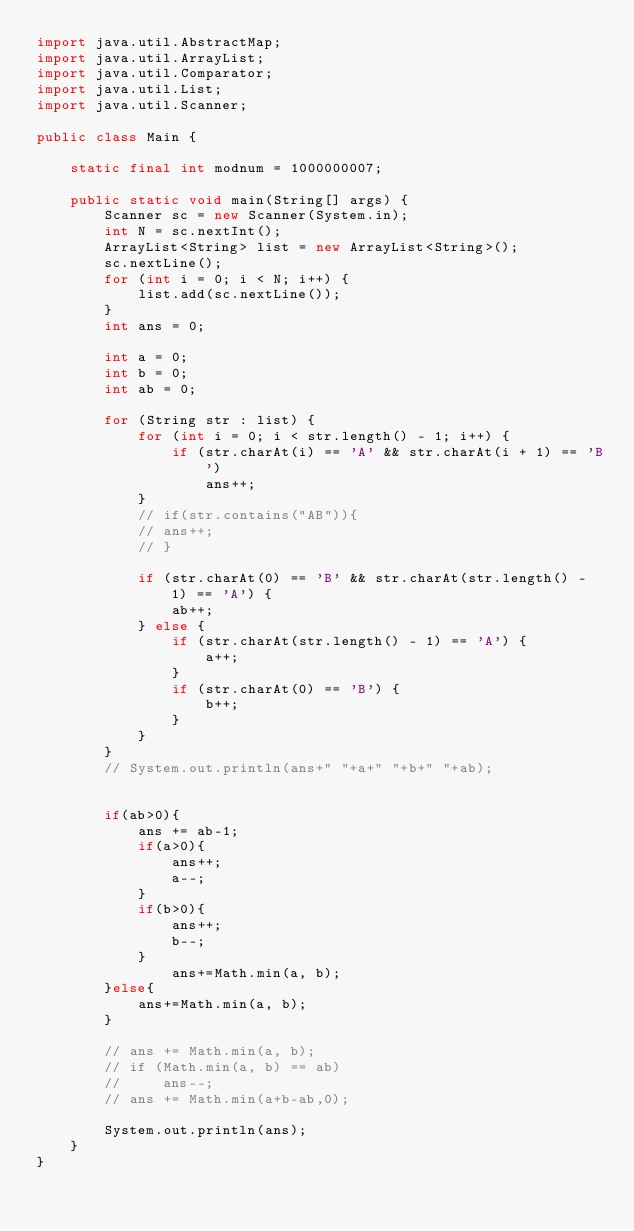<code> <loc_0><loc_0><loc_500><loc_500><_Java_>import java.util.AbstractMap;
import java.util.ArrayList;
import java.util.Comparator;
import java.util.List;
import java.util.Scanner;

public class Main {

    static final int modnum = 1000000007;

    public static void main(String[] args) {
        Scanner sc = new Scanner(System.in);
        int N = sc.nextInt();
        ArrayList<String> list = new ArrayList<String>();
        sc.nextLine();
        for (int i = 0; i < N; i++) {
            list.add(sc.nextLine());
        }
        int ans = 0;

        int a = 0;
        int b = 0;
        int ab = 0;

        for (String str : list) {
            for (int i = 0; i < str.length() - 1; i++) {
                if (str.charAt(i) == 'A' && str.charAt(i + 1) == 'B')
                    ans++;
            }
            // if(str.contains("AB")){
            // ans++;
            // }

            if (str.charAt(0) == 'B' && str.charAt(str.length() - 1) == 'A') {
                ab++;
            } else {
                if (str.charAt(str.length() - 1) == 'A') {
                    a++;
                }
                if (str.charAt(0) == 'B') {
                    b++;
                }
            }
        }
        // System.out.println(ans+" "+a+" "+b+" "+ab);


        if(ab>0){
            ans += ab-1;
            if(a>0){
                ans++;
                a--;
            }
            if(b>0){
                ans++;
                b--;
            }
                ans+=Math.min(a, b);
        }else{
            ans+=Math.min(a, b);
        }

        // ans += Math.min(a, b);
        // if (Math.min(a, b) == ab)
        //     ans--;
        // ans += Math.min(a+b-ab,0);

        System.out.println(ans);
    }
}</code> 